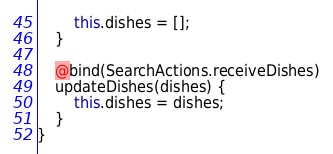Convert code to text. <code><loc_0><loc_0><loc_500><loc_500><_JavaScript_>		this.dishes = [];
	}

	@bind(SearchActions.receiveDishes)
	updateDishes(dishes) {
		this.dishes = dishes;
	}
}</code> 